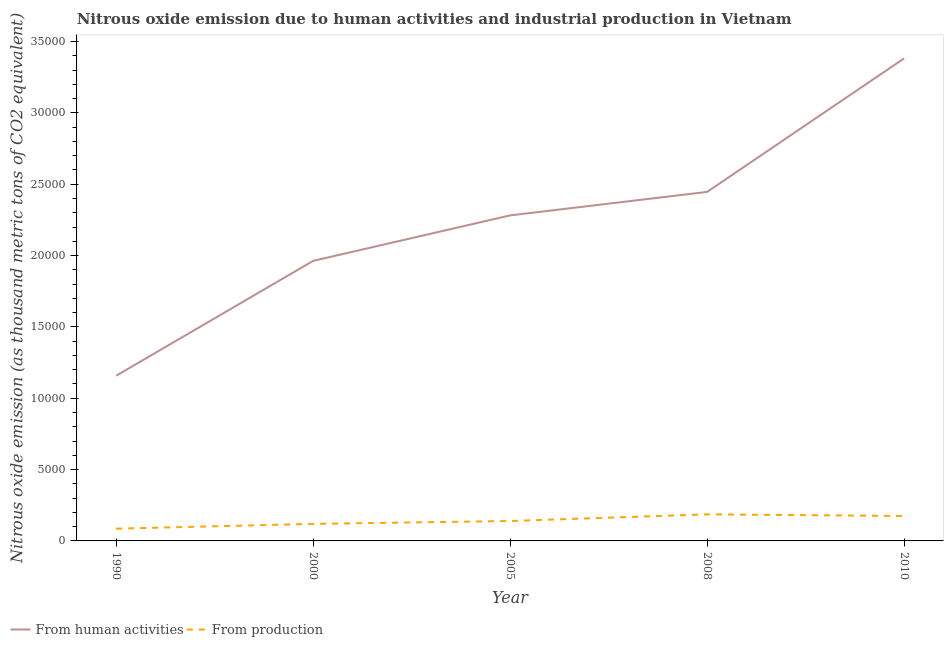How many different coloured lines are there?
Offer a terse response. 2. What is the amount of emissions generated from industries in 2000?
Give a very brief answer. 1195.6. Across all years, what is the maximum amount of emissions generated from industries?
Your answer should be very brief. 1861.6. Across all years, what is the minimum amount of emissions generated from industries?
Make the answer very short. 857.4. In which year was the amount of emissions from human activities maximum?
Make the answer very short. 2010. In which year was the amount of emissions from human activities minimum?
Offer a terse response. 1990. What is the total amount of emissions from human activities in the graph?
Your answer should be compact. 1.12e+05. What is the difference between the amount of emissions from human activities in 1990 and that in 2010?
Your answer should be compact. -2.22e+04. What is the difference between the amount of emissions generated from industries in 2005 and the amount of emissions from human activities in 2010?
Provide a short and direct response. -3.24e+04. What is the average amount of emissions from human activities per year?
Offer a very short reply. 2.25e+04. In the year 2008, what is the difference between the amount of emissions generated from industries and amount of emissions from human activities?
Ensure brevity in your answer.  -2.26e+04. What is the ratio of the amount of emissions generated from industries in 2000 to that in 2008?
Your answer should be compact. 0.64. What is the difference between the highest and the second highest amount of emissions generated from industries?
Your response must be concise. 112.5. What is the difference between the highest and the lowest amount of emissions from human activities?
Provide a short and direct response. 2.22e+04. Is the sum of the amount of emissions from human activities in 1990 and 2000 greater than the maximum amount of emissions generated from industries across all years?
Keep it short and to the point. Yes. Does the amount of emissions generated from industries monotonically increase over the years?
Your response must be concise. No. What is the difference between two consecutive major ticks on the Y-axis?
Ensure brevity in your answer.  5000. Are the values on the major ticks of Y-axis written in scientific E-notation?
Your answer should be very brief. No. How many legend labels are there?
Give a very brief answer. 2. What is the title of the graph?
Make the answer very short. Nitrous oxide emission due to human activities and industrial production in Vietnam. What is the label or title of the X-axis?
Ensure brevity in your answer.  Year. What is the label or title of the Y-axis?
Give a very brief answer. Nitrous oxide emission (as thousand metric tons of CO2 equivalent). What is the Nitrous oxide emission (as thousand metric tons of CO2 equivalent) in From human activities in 1990?
Make the answer very short. 1.16e+04. What is the Nitrous oxide emission (as thousand metric tons of CO2 equivalent) in From production in 1990?
Provide a succinct answer. 857.4. What is the Nitrous oxide emission (as thousand metric tons of CO2 equivalent) of From human activities in 2000?
Keep it short and to the point. 1.96e+04. What is the Nitrous oxide emission (as thousand metric tons of CO2 equivalent) in From production in 2000?
Offer a terse response. 1195.6. What is the Nitrous oxide emission (as thousand metric tons of CO2 equivalent) of From human activities in 2005?
Make the answer very short. 2.28e+04. What is the Nitrous oxide emission (as thousand metric tons of CO2 equivalent) of From production in 2005?
Ensure brevity in your answer.  1396.4. What is the Nitrous oxide emission (as thousand metric tons of CO2 equivalent) of From human activities in 2008?
Provide a short and direct response. 2.45e+04. What is the Nitrous oxide emission (as thousand metric tons of CO2 equivalent) in From production in 2008?
Your answer should be compact. 1861.6. What is the Nitrous oxide emission (as thousand metric tons of CO2 equivalent) in From human activities in 2010?
Keep it short and to the point. 3.38e+04. What is the Nitrous oxide emission (as thousand metric tons of CO2 equivalent) in From production in 2010?
Offer a terse response. 1749.1. Across all years, what is the maximum Nitrous oxide emission (as thousand metric tons of CO2 equivalent) in From human activities?
Keep it short and to the point. 3.38e+04. Across all years, what is the maximum Nitrous oxide emission (as thousand metric tons of CO2 equivalent) of From production?
Your answer should be compact. 1861.6. Across all years, what is the minimum Nitrous oxide emission (as thousand metric tons of CO2 equivalent) of From human activities?
Offer a very short reply. 1.16e+04. Across all years, what is the minimum Nitrous oxide emission (as thousand metric tons of CO2 equivalent) of From production?
Your answer should be very brief. 857.4. What is the total Nitrous oxide emission (as thousand metric tons of CO2 equivalent) in From human activities in the graph?
Ensure brevity in your answer.  1.12e+05. What is the total Nitrous oxide emission (as thousand metric tons of CO2 equivalent) in From production in the graph?
Offer a very short reply. 7060.1. What is the difference between the Nitrous oxide emission (as thousand metric tons of CO2 equivalent) in From human activities in 1990 and that in 2000?
Offer a terse response. -8050.5. What is the difference between the Nitrous oxide emission (as thousand metric tons of CO2 equivalent) in From production in 1990 and that in 2000?
Offer a terse response. -338.2. What is the difference between the Nitrous oxide emission (as thousand metric tons of CO2 equivalent) in From human activities in 1990 and that in 2005?
Offer a very short reply. -1.12e+04. What is the difference between the Nitrous oxide emission (as thousand metric tons of CO2 equivalent) of From production in 1990 and that in 2005?
Ensure brevity in your answer.  -539. What is the difference between the Nitrous oxide emission (as thousand metric tons of CO2 equivalent) of From human activities in 1990 and that in 2008?
Offer a terse response. -1.29e+04. What is the difference between the Nitrous oxide emission (as thousand metric tons of CO2 equivalent) in From production in 1990 and that in 2008?
Make the answer very short. -1004.2. What is the difference between the Nitrous oxide emission (as thousand metric tons of CO2 equivalent) of From human activities in 1990 and that in 2010?
Ensure brevity in your answer.  -2.22e+04. What is the difference between the Nitrous oxide emission (as thousand metric tons of CO2 equivalent) in From production in 1990 and that in 2010?
Ensure brevity in your answer.  -891.7. What is the difference between the Nitrous oxide emission (as thousand metric tons of CO2 equivalent) of From human activities in 2000 and that in 2005?
Make the answer very short. -3186.8. What is the difference between the Nitrous oxide emission (as thousand metric tons of CO2 equivalent) of From production in 2000 and that in 2005?
Provide a succinct answer. -200.8. What is the difference between the Nitrous oxide emission (as thousand metric tons of CO2 equivalent) of From human activities in 2000 and that in 2008?
Give a very brief answer. -4832.2. What is the difference between the Nitrous oxide emission (as thousand metric tons of CO2 equivalent) in From production in 2000 and that in 2008?
Your response must be concise. -666. What is the difference between the Nitrous oxide emission (as thousand metric tons of CO2 equivalent) in From human activities in 2000 and that in 2010?
Your answer should be very brief. -1.42e+04. What is the difference between the Nitrous oxide emission (as thousand metric tons of CO2 equivalent) in From production in 2000 and that in 2010?
Keep it short and to the point. -553.5. What is the difference between the Nitrous oxide emission (as thousand metric tons of CO2 equivalent) of From human activities in 2005 and that in 2008?
Ensure brevity in your answer.  -1645.4. What is the difference between the Nitrous oxide emission (as thousand metric tons of CO2 equivalent) in From production in 2005 and that in 2008?
Offer a terse response. -465.2. What is the difference between the Nitrous oxide emission (as thousand metric tons of CO2 equivalent) in From human activities in 2005 and that in 2010?
Offer a very short reply. -1.10e+04. What is the difference between the Nitrous oxide emission (as thousand metric tons of CO2 equivalent) of From production in 2005 and that in 2010?
Offer a very short reply. -352.7. What is the difference between the Nitrous oxide emission (as thousand metric tons of CO2 equivalent) of From human activities in 2008 and that in 2010?
Keep it short and to the point. -9358.4. What is the difference between the Nitrous oxide emission (as thousand metric tons of CO2 equivalent) in From production in 2008 and that in 2010?
Your answer should be very brief. 112.5. What is the difference between the Nitrous oxide emission (as thousand metric tons of CO2 equivalent) in From human activities in 1990 and the Nitrous oxide emission (as thousand metric tons of CO2 equivalent) in From production in 2000?
Keep it short and to the point. 1.04e+04. What is the difference between the Nitrous oxide emission (as thousand metric tons of CO2 equivalent) in From human activities in 1990 and the Nitrous oxide emission (as thousand metric tons of CO2 equivalent) in From production in 2005?
Your answer should be compact. 1.02e+04. What is the difference between the Nitrous oxide emission (as thousand metric tons of CO2 equivalent) of From human activities in 1990 and the Nitrous oxide emission (as thousand metric tons of CO2 equivalent) of From production in 2008?
Provide a short and direct response. 9715.2. What is the difference between the Nitrous oxide emission (as thousand metric tons of CO2 equivalent) of From human activities in 1990 and the Nitrous oxide emission (as thousand metric tons of CO2 equivalent) of From production in 2010?
Make the answer very short. 9827.7. What is the difference between the Nitrous oxide emission (as thousand metric tons of CO2 equivalent) of From human activities in 2000 and the Nitrous oxide emission (as thousand metric tons of CO2 equivalent) of From production in 2005?
Offer a terse response. 1.82e+04. What is the difference between the Nitrous oxide emission (as thousand metric tons of CO2 equivalent) in From human activities in 2000 and the Nitrous oxide emission (as thousand metric tons of CO2 equivalent) in From production in 2008?
Offer a very short reply. 1.78e+04. What is the difference between the Nitrous oxide emission (as thousand metric tons of CO2 equivalent) of From human activities in 2000 and the Nitrous oxide emission (as thousand metric tons of CO2 equivalent) of From production in 2010?
Ensure brevity in your answer.  1.79e+04. What is the difference between the Nitrous oxide emission (as thousand metric tons of CO2 equivalent) in From human activities in 2005 and the Nitrous oxide emission (as thousand metric tons of CO2 equivalent) in From production in 2008?
Make the answer very short. 2.10e+04. What is the difference between the Nitrous oxide emission (as thousand metric tons of CO2 equivalent) in From human activities in 2005 and the Nitrous oxide emission (as thousand metric tons of CO2 equivalent) in From production in 2010?
Provide a succinct answer. 2.11e+04. What is the difference between the Nitrous oxide emission (as thousand metric tons of CO2 equivalent) of From human activities in 2008 and the Nitrous oxide emission (as thousand metric tons of CO2 equivalent) of From production in 2010?
Give a very brief answer. 2.27e+04. What is the average Nitrous oxide emission (as thousand metric tons of CO2 equivalent) of From human activities per year?
Make the answer very short. 2.25e+04. What is the average Nitrous oxide emission (as thousand metric tons of CO2 equivalent) in From production per year?
Your answer should be very brief. 1412.02. In the year 1990, what is the difference between the Nitrous oxide emission (as thousand metric tons of CO2 equivalent) in From human activities and Nitrous oxide emission (as thousand metric tons of CO2 equivalent) in From production?
Ensure brevity in your answer.  1.07e+04. In the year 2000, what is the difference between the Nitrous oxide emission (as thousand metric tons of CO2 equivalent) of From human activities and Nitrous oxide emission (as thousand metric tons of CO2 equivalent) of From production?
Ensure brevity in your answer.  1.84e+04. In the year 2005, what is the difference between the Nitrous oxide emission (as thousand metric tons of CO2 equivalent) of From human activities and Nitrous oxide emission (as thousand metric tons of CO2 equivalent) of From production?
Provide a succinct answer. 2.14e+04. In the year 2008, what is the difference between the Nitrous oxide emission (as thousand metric tons of CO2 equivalent) in From human activities and Nitrous oxide emission (as thousand metric tons of CO2 equivalent) in From production?
Provide a short and direct response. 2.26e+04. In the year 2010, what is the difference between the Nitrous oxide emission (as thousand metric tons of CO2 equivalent) in From human activities and Nitrous oxide emission (as thousand metric tons of CO2 equivalent) in From production?
Your response must be concise. 3.21e+04. What is the ratio of the Nitrous oxide emission (as thousand metric tons of CO2 equivalent) of From human activities in 1990 to that in 2000?
Your response must be concise. 0.59. What is the ratio of the Nitrous oxide emission (as thousand metric tons of CO2 equivalent) in From production in 1990 to that in 2000?
Keep it short and to the point. 0.72. What is the ratio of the Nitrous oxide emission (as thousand metric tons of CO2 equivalent) of From human activities in 1990 to that in 2005?
Provide a short and direct response. 0.51. What is the ratio of the Nitrous oxide emission (as thousand metric tons of CO2 equivalent) in From production in 1990 to that in 2005?
Provide a succinct answer. 0.61. What is the ratio of the Nitrous oxide emission (as thousand metric tons of CO2 equivalent) in From human activities in 1990 to that in 2008?
Provide a succinct answer. 0.47. What is the ratio of the Nitrous oxide emission (as thousand metric tons of CO2 equivalent) of From production in 1990 to that in 2008?
Make the answer very short. 0.46. What is the ratio of the Nitrous oxide emission (as thousand metric tons of CO2 equivalent) in From human activities in 1990 to that in 2010?
Ensure brevity in your answer.  0.34. What is the ratio of the Nitrous oxide emission (as thousand metric tons of CO2 equivalent) in From production in 1990 to that in 2010?
Give a very brief answer. 0.49. What is the ratio of the Nitrous oxide emission (as thousand metric tons of CO2 equivalent) of From human activities in 2000 to that in 2005?
Provide a short and direct response. 0.86. What is the ratio of the Nitrous oxide emission (as thousand metric tons of CO2 equivalent) of From production in 2000 to that in 2005?
Provide a succinct answer. 0.86. What is the ratio of the Nitrous oxide emission (as thousand metric tons of CO2 equivalent) in From human activities in 2000 to that in 2008?
Keep it short and to the point. 0.8. What is the ratio of the Nitrous oxide emission (as thousand metric tons of CO2 equivalent) in From production in 2000 to that in 2008?
Your answer should be very brief. 0.64. What is the ratio of the Nitrous oxide emission (as thousand metric tons of CO2 equivalent) in From human activities in 2000 to that in 2010?
Your answer should be compact. 0.58. What is the ratio of the Nitrous oxide emission (as thousand metric tons of CO2 equivalent) of From production in 2000 to that in 2010?
Your answer should be compact. 0.68. What is the ratio of the Nitrous oxide emission (as thousand metric tons of CO2 equivalent) of From human activities in 2005 to that in 2008?
Give a very brief answer. 0.93. What is the ratio of the Nitrous oxide emission (as thousand metric tons of CO2 equivalent) of From production in 2005 to that in 2008?
Offer a very short reply. 0.75. What is the ratio of the Nitrous oxide emission (as thousand metric tons of CO2 equivalent) in From human activities in 2005 to that in 2010?
Provide a succinct answer. 0.67. What is the ratio of the Nitrous oxide emission (as thousand metric tons of CO2 equivalent) of From production in 2005 to that in 2010?
Keep it short and to the point. 0.8. What is the ratio of the Nitrous oxide emission (as thousand metric tons of CO2 equivalent) in From human activities in 2008 to that in 2010?
Your answer should be compact. 0.72. What is the ratio of the Nitrous oxide emission (as thousand metric tons of CO2 equivalent) of From production in 2008 to that in 2010?
Make the answer very short. 1.06. What is the difference between the highest and the second highest Nitrous oxide emission (as thousand metric tons of CO2 equivalent) of From human activities?
Your answer should be compact. 9358.4. What is the difference between the highest and the second highest Nitrous oxide emission (as thousand metric tons of CO2 equivalent) in From production?
Give a very brief answer. 112.5. What is the difference between the highest and the lowest Nitrous oxide emission (as thousand metric tons of CO2 equivalent) of From human activities?
Your response must be concise. 2.22e+04. What is the difference between the highest and the lowest Nitrous oxide emission (as thousand metric tons of CO2 equivalent) in From production?
Keep it short and to the point. 1004.2. 